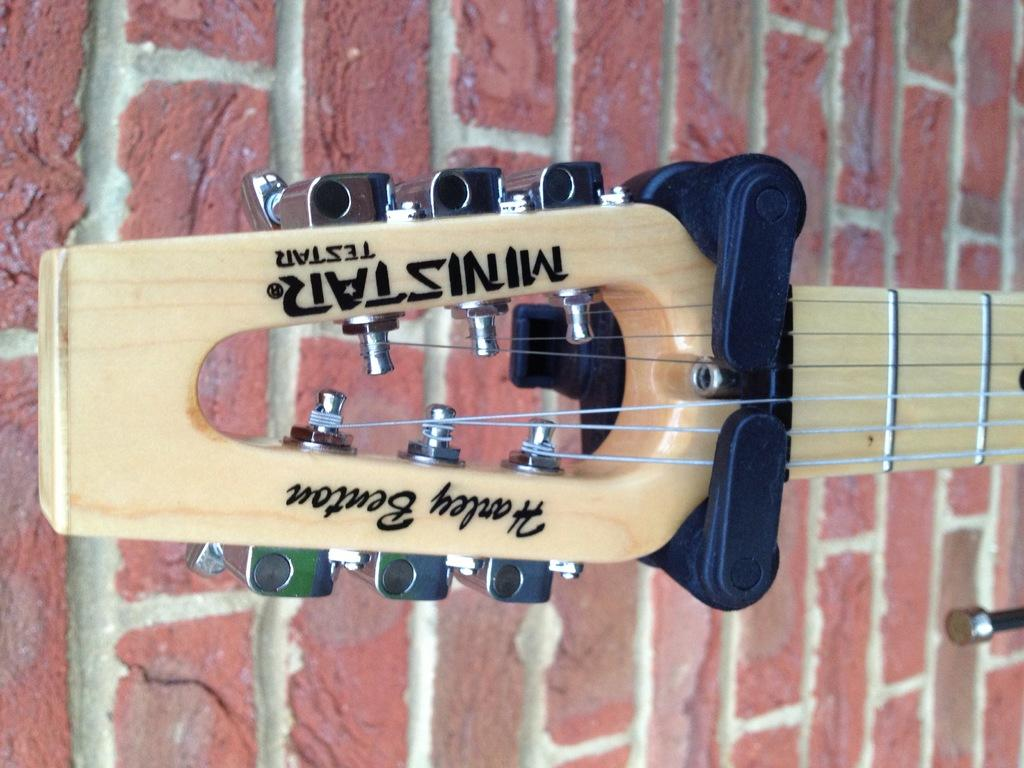What musical instrument is visible in the image? There is a guitar in the image. Where is the guitar located in relation to the rest of the image? The guitar is in the background of the image. What other object can be seen in the image? There is a wall in the image. What type of pet is sitting on the bed in the image? There is no pet or bed present in the image; it only features a guitar and a wall. What type of eggnog is being served in the image? There is no eggnog present in the image. 